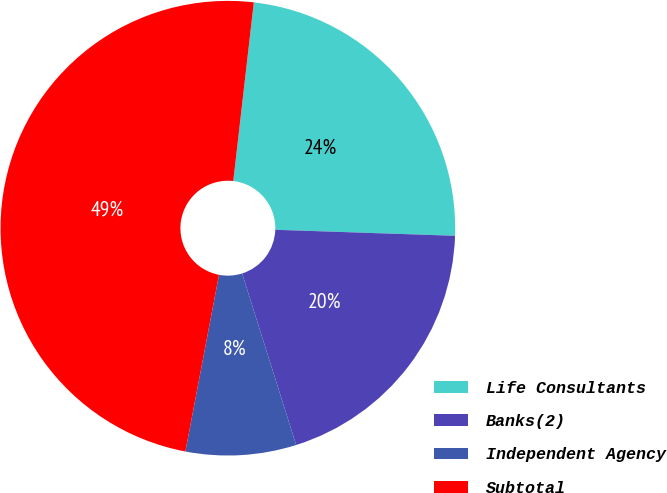Convert chart to OTSL. <chart><loc_0><loc_0><loc_500><loc_500><pie_chart><fcel>Life Consultants<fcel>Banks(2)<fcel>Independent Agency<fcel>Subtotal<nl><fcel>23.71%<fcel>19.61%<fcel>7.85%<fcel>48.83%<nl></chart> 